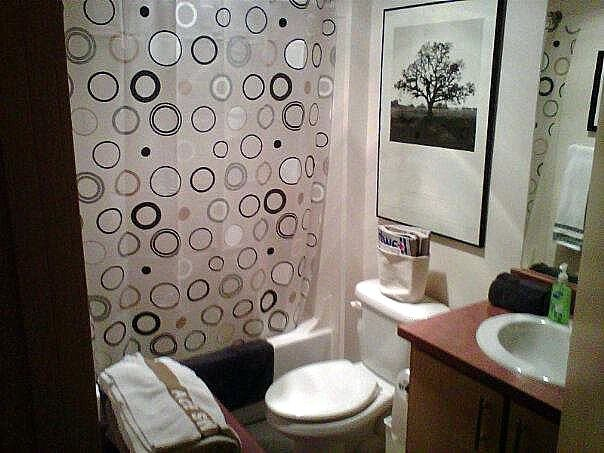Describe the objects in this image and their specific colors. I can see toilet in black, white, darkgray, and gray tones, sink in black, darkgray, gray, and lightgray tones, bottle in black, darkgreen, and green tones, potted plant in black, darkgreen, and green tones, and book in black, darkgray, gray, and lightgray tones in this image. 